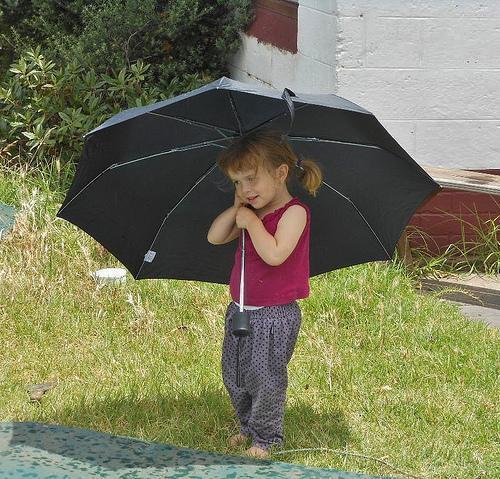How many girls are there?
Give a very brief answer. 1. 